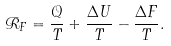Convert formula to latex. <formula><loc_0><loc_0><loc_500><loc_500>\mathcal { R } _ { F } = \frac { \mathcal { Q } } { T } + \frac { \Delta U } { T } - \frac { \Delta F } { T } .</formula> 